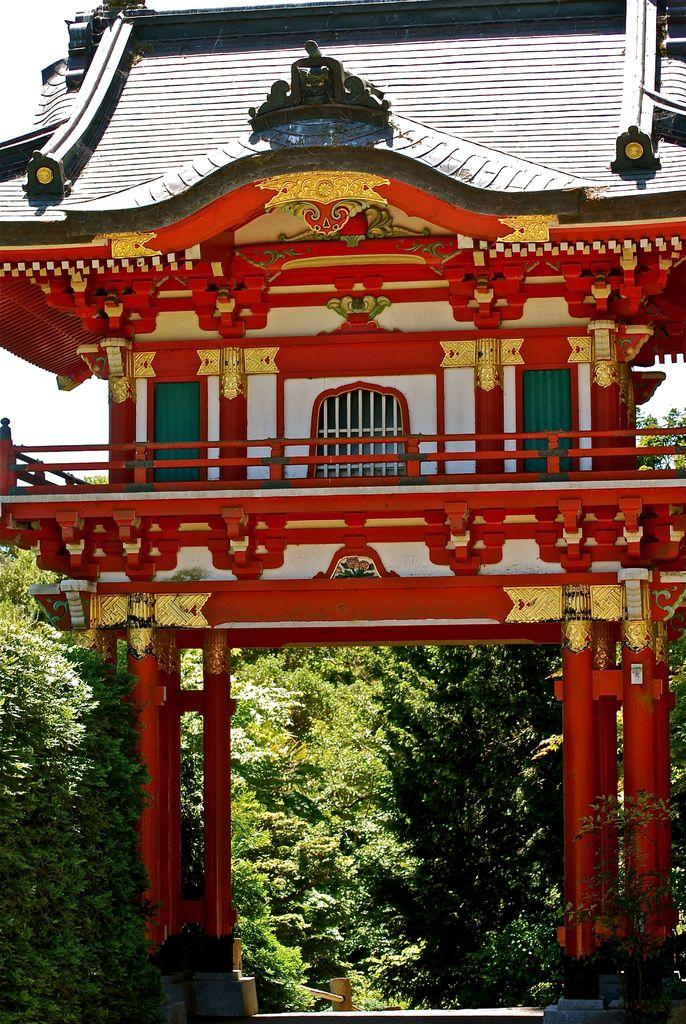What type of building is in the image? There is a temple in the image. What architectural features can be seen in the temple? There are pillars in the image. What type of vegetation is present in the image? There are trees in the image. What can be seen in the background of the image? The sky is visible in the background of the image. What type of joke is being told by the jellyfish in the image? There are no jellyfish present in the image, and therefore no joke can be observed. 